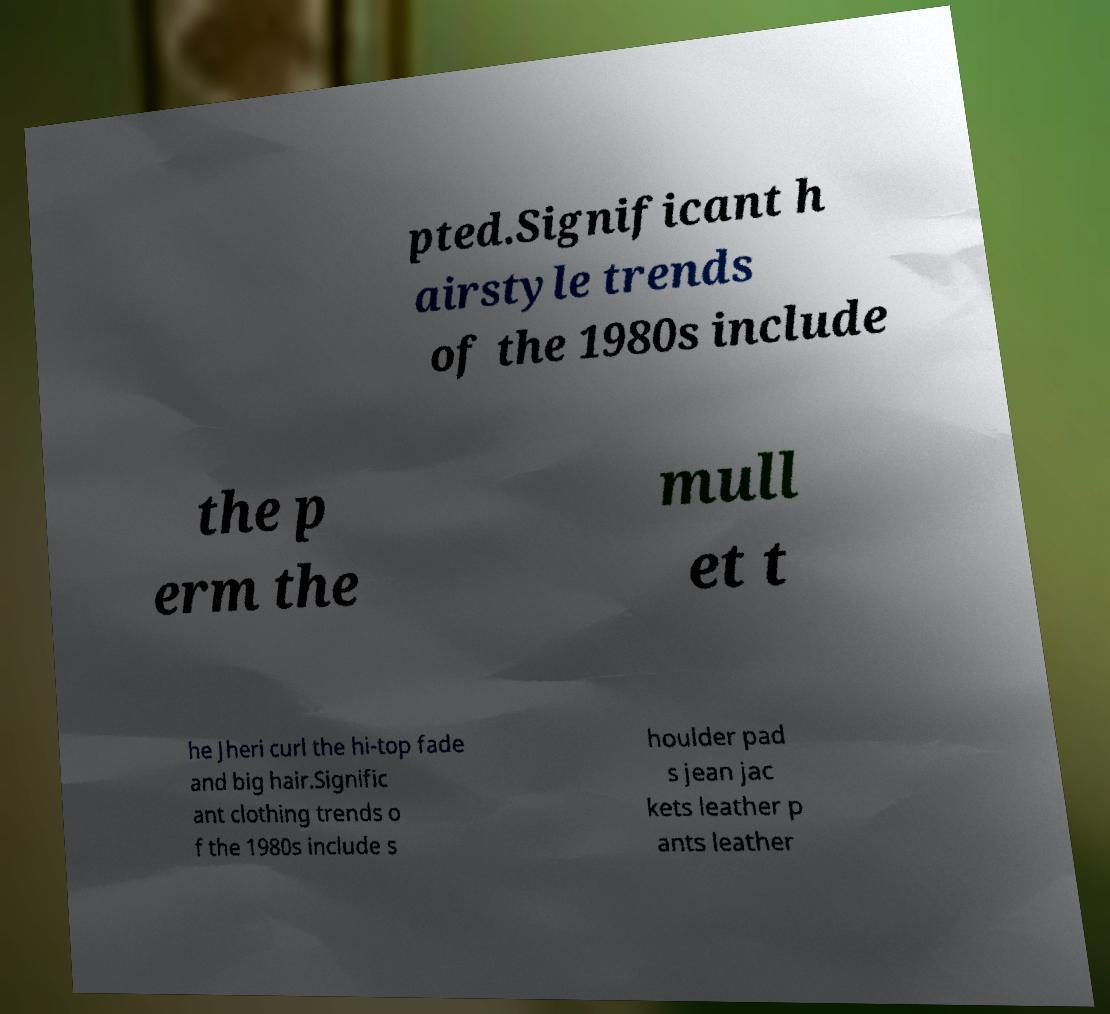Can you accurately transcribe the text from the provided image for me? pted.Significant h airstyle trends of the 1980s include the p erm the mull et t he Jheri curl the hi-top fade and big hair.Signific ant clothing trends o f the 1980s include s houlder pad s jean jac kets leather p ants leather 